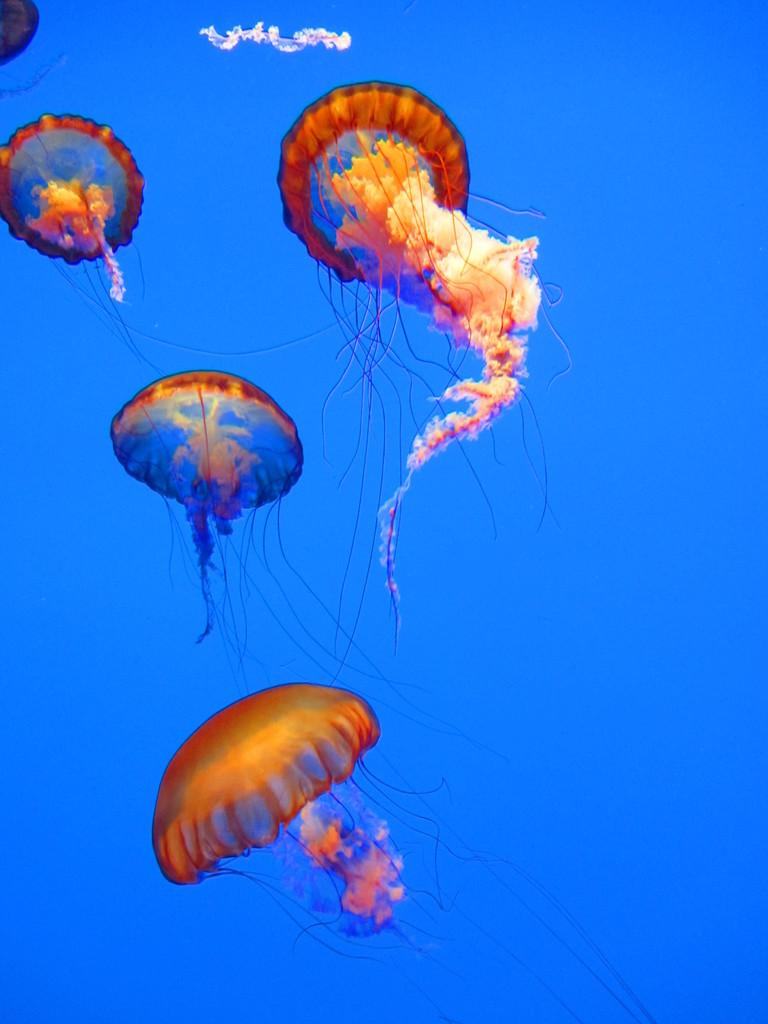What is the main subject of the image? The main subject of the image is air balloons. What can be seen in the background of the image? The sky is visible at the top of the image. What is present near the air balloons? There is smoke near the air balloons. What type of crow can be seen sitting on the air balloon in the image? There is no crow present in the image; it only features air balloons and smoke. What scent is associated with the air balloons in the image? The image does not provide any information about the scent of the air balloons. 